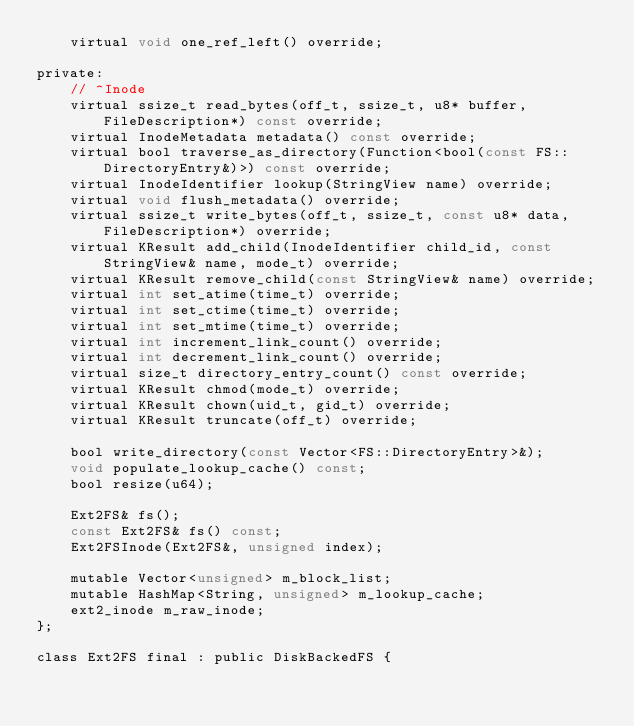Convert code to text. <code><loc_0><loc_0><loc_500><loc_500><_C_>    virtual void one_ref_left() override;

private:
    // ^Inode
    virtual ssize_t read_bytes(off_t, ssize_t, u8* buffer, FileDescription*) const override;
    virtual InodeMetadata metadata() const override;
    virtual bool traverse_as_directory(Function<bool(const FS::DirectoryEntry&)>) const override;
    virtual InodeIdentifier lookup(StringView name) override;
    virtual void flush_metadata() override;
    virtual ssize_t write_bytes(off_t, ssize_t, const u8* data, FileDescription*) override;
    virtual KResult add_child(InodeIdentifier child_id, const StringView& name, mode_t) override;
    virtual KResult remove_child(const StringView& name) override;
    virtual int set_atime(time_t) override;
    virtual int set_ctime(time_t) override;
    virtual int set_mtime(time_t) override;
    virtual int increment_link_count() override;
    virtual int decrement_link_count() override;
    virtual size_t directory_entry_count() const override;
    virtual KResult chmod(mode_t) override;
    virtual KResult chown(uid_t, gid_t) override;
    virtual KResult truncate(off_t) override;

    bool write_directory(const Vector<FS::DirectoryEntry>&);
    void populate_lookup_cache() const;
    bool resize(u64);

    Ext2FS& fs();
    const Ext2FS& fs() const;
    Ext2FSInode(Ext2FS&, unsigned index);

    mutable Vector<unsigned> m_block_list;
    mutable HashMap<String, unsigned> m_lookup_cache;
    ext2_inode m_raw_inode;
};

class Ext2FS final : public DiskBackedFS {</code> 